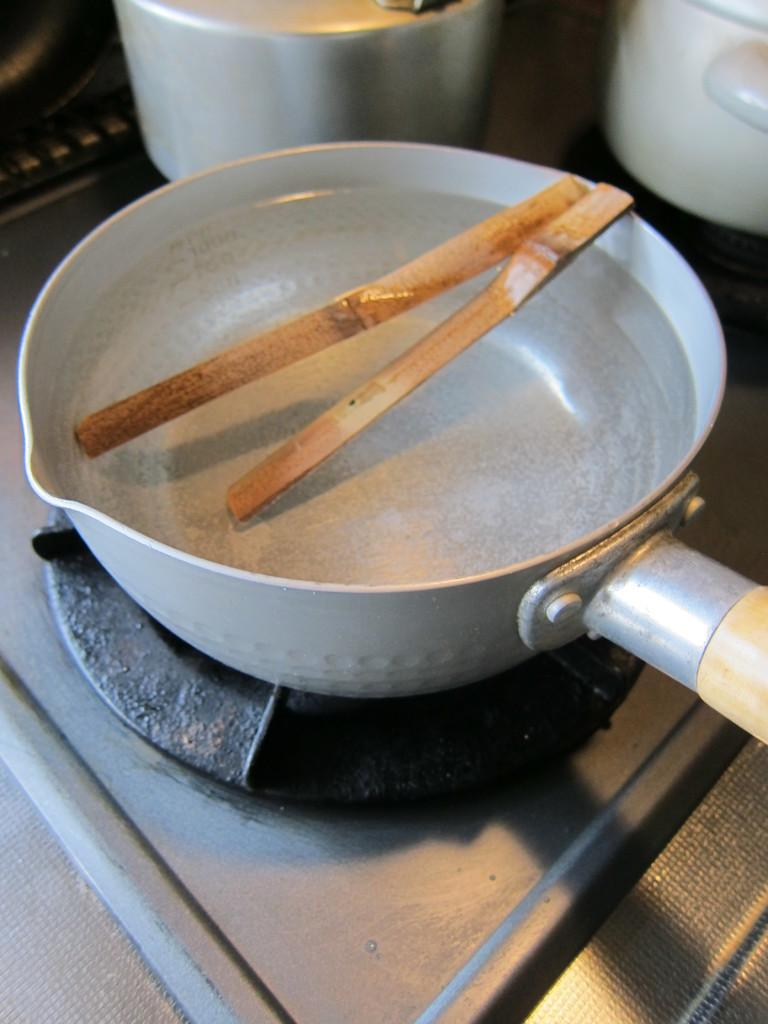What is the main object in the image? There is a vessel in the image. What is inside the vessel? The vessel contains water. Where is the vessel located? The vessel is on a stove. What else can be seen in the vessel? There are sticks in the vessel. How does the beginner learn to open the gate in the image? There is no gate present in the image, so it's not possible to answer that question. 